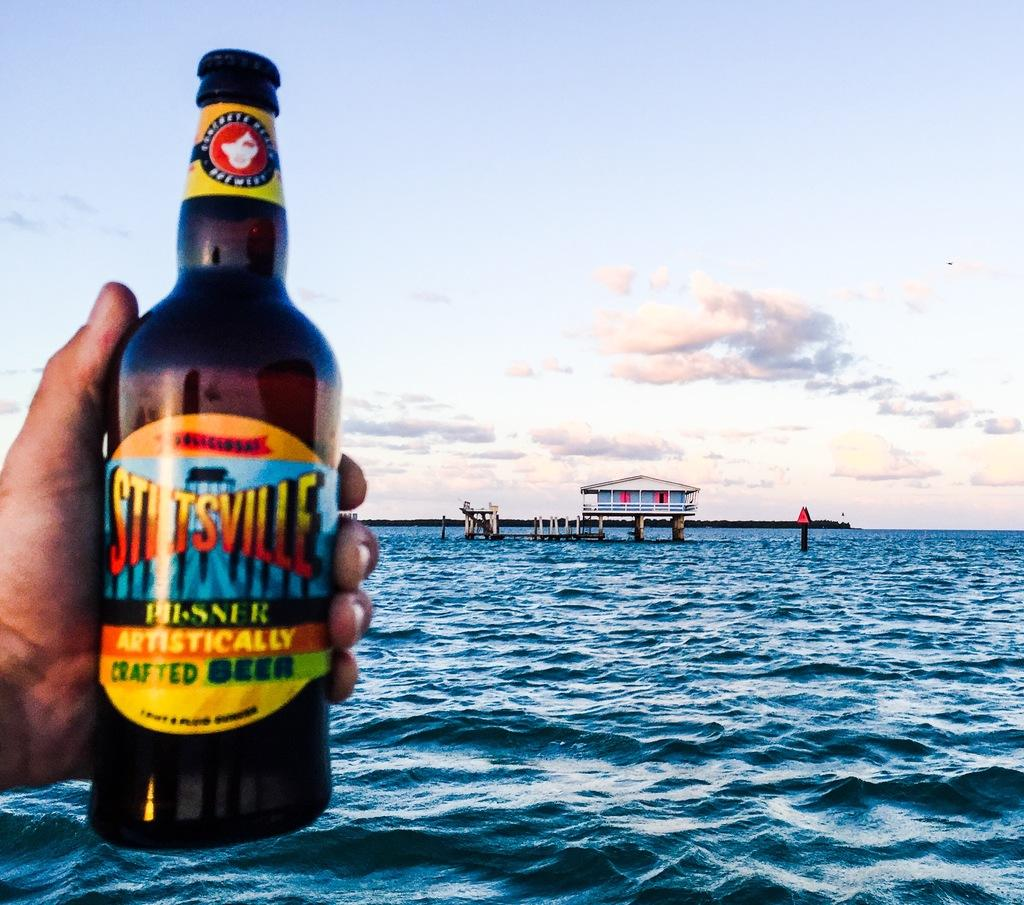<image>
Offer a succinct explanation of the picture presented. A man is holding up a bottle of Stiltsville Craft Beer in front of a body of water. 